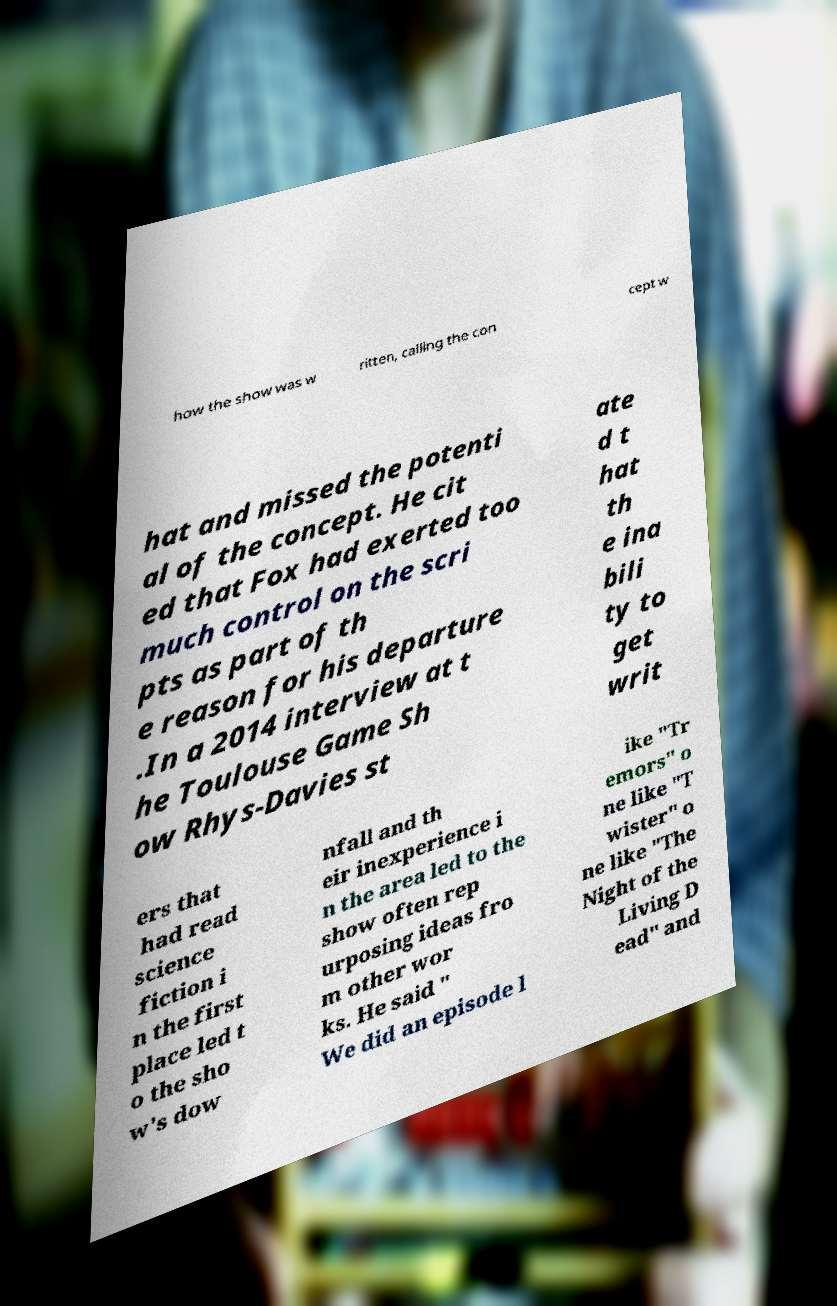I need the written content from this picture converted into text. Can you do that? how the show was w ritten, calling the con cept w hat and missed the potenti al of the concept. He cit ed that Fox had exerted too much control on the scri pts as part of th e reason for his departure .In a 2014 interview at t he Toulouse Game Sh ow Rhys-Davies st ate d t hat th e ina bili ty to get writ ers that had read science fiction i n the first place led t o the sho w's dow nfall and th eir inexperience i n the area led to the show often rep urposing ideas fro m other wor ks. He said " We did an episode l ike "Tr emors" o ne like "T wister" o ne like "The Night of the Living D ead" and 